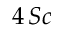Convert formula to latex. <formula><loc_0><loc_0><loc_500><loc_500>4 \, S c</formula> 